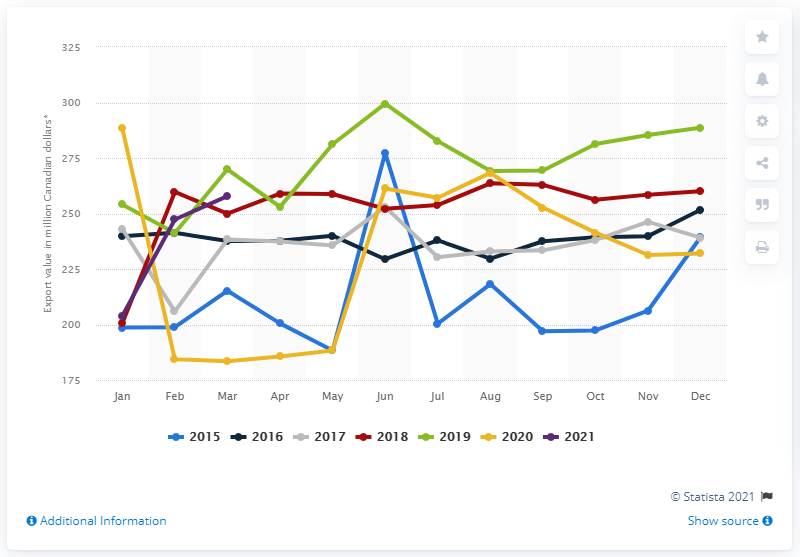Draw attention to some important aspects in this diagram. In March 2021, the export value of fish, crustaceans, shellfish, and other fishery products from Canada was CAD 260 million. 